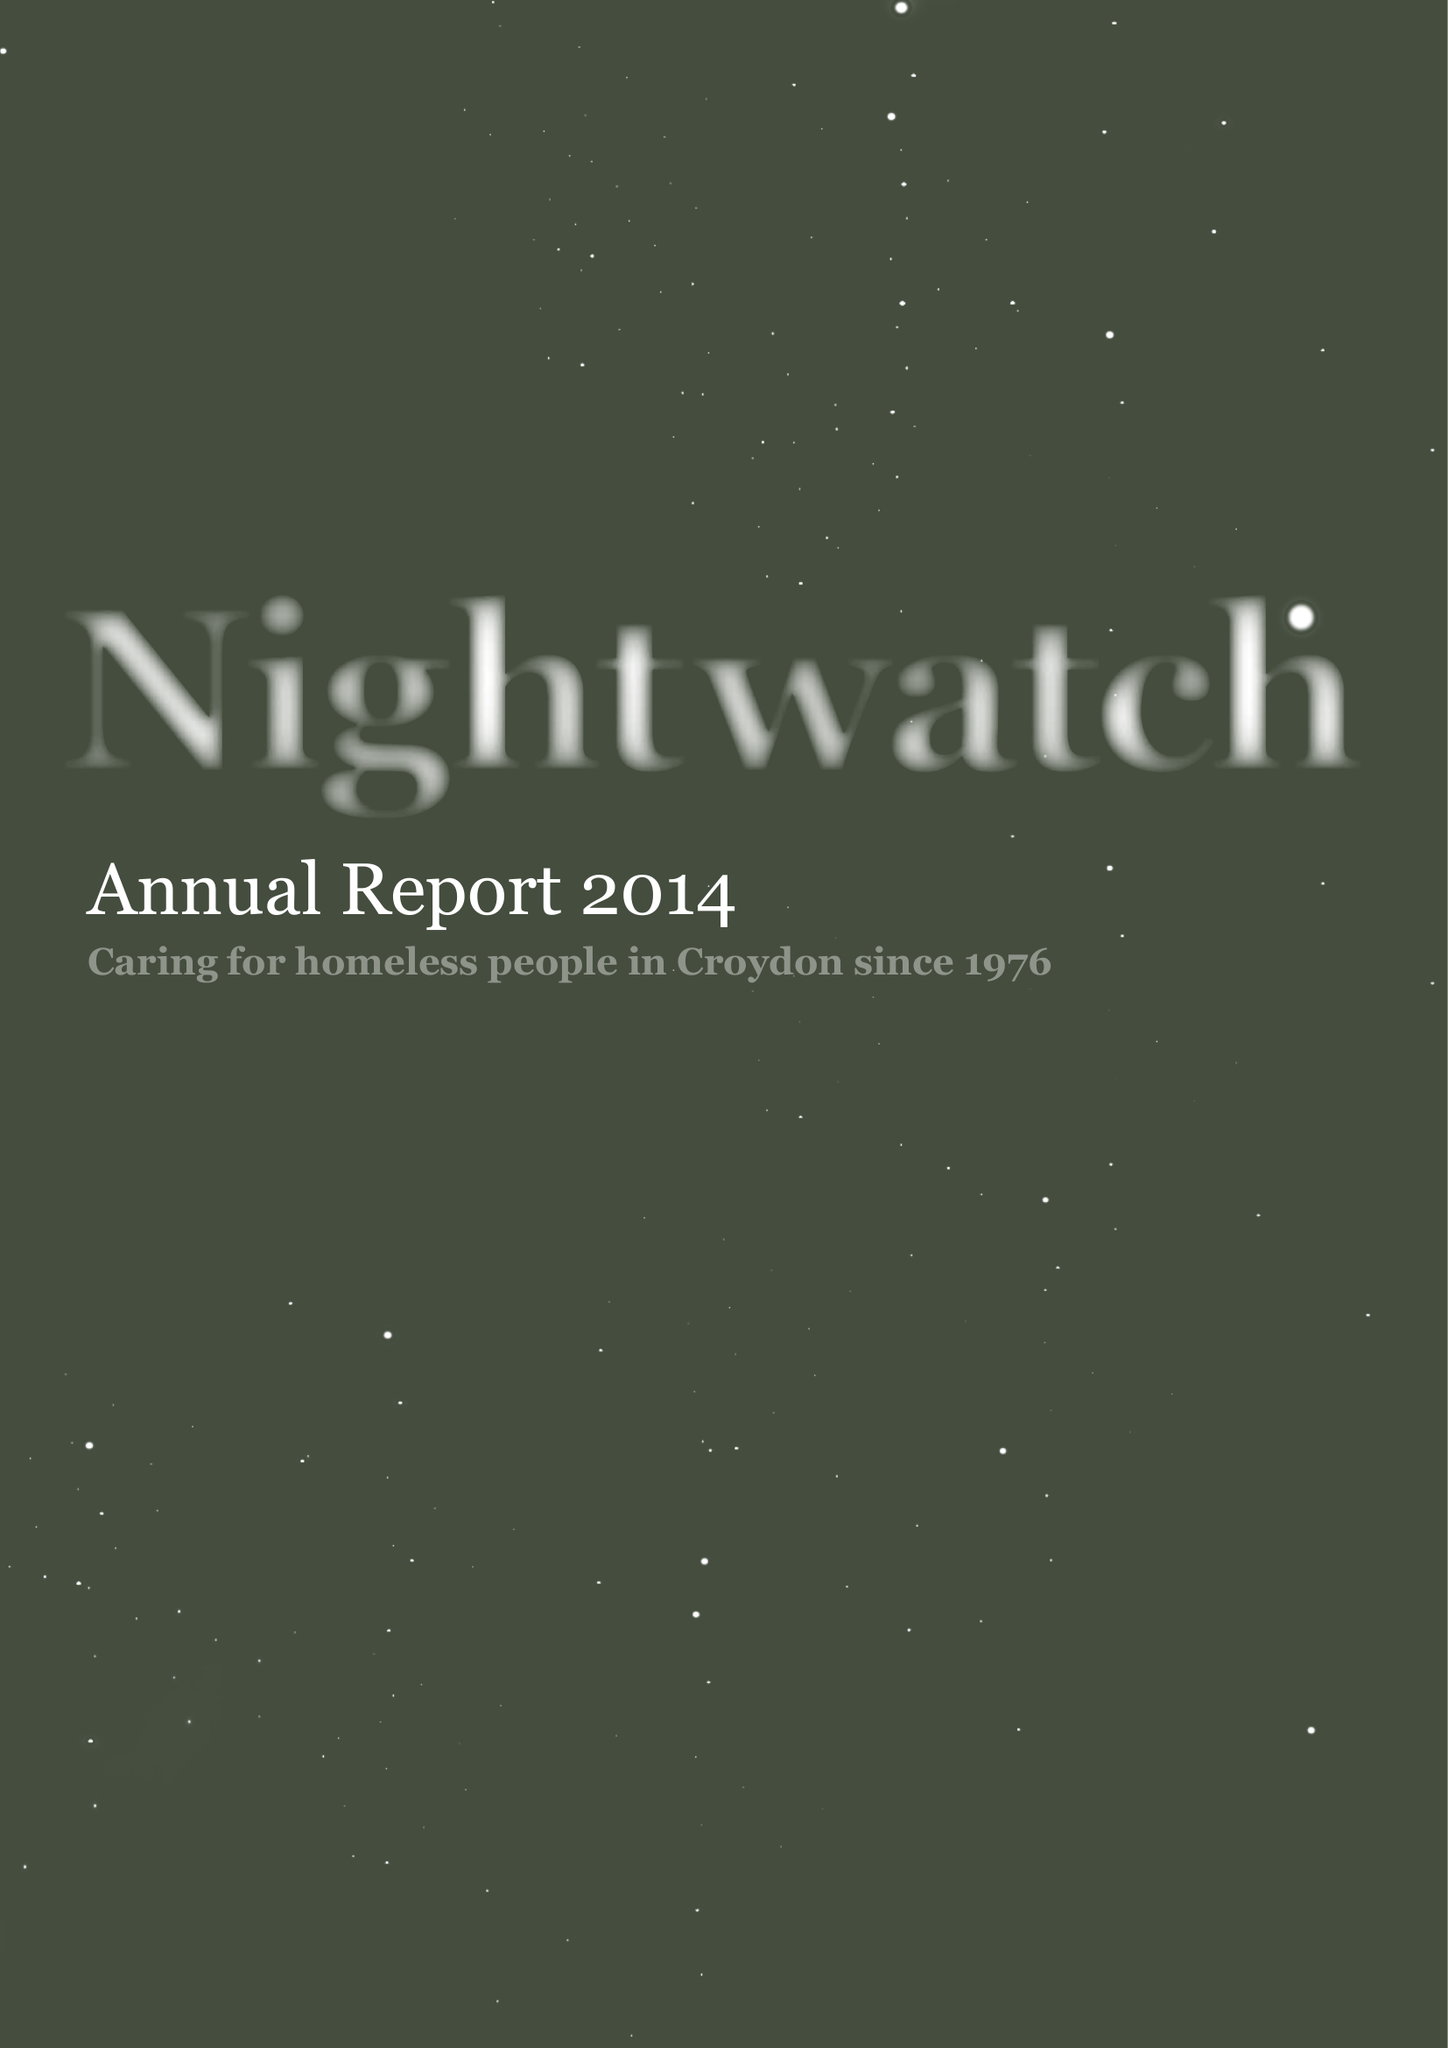What is the value for the address__post_town?
Answer the question using a single word or phrase. LONDON 